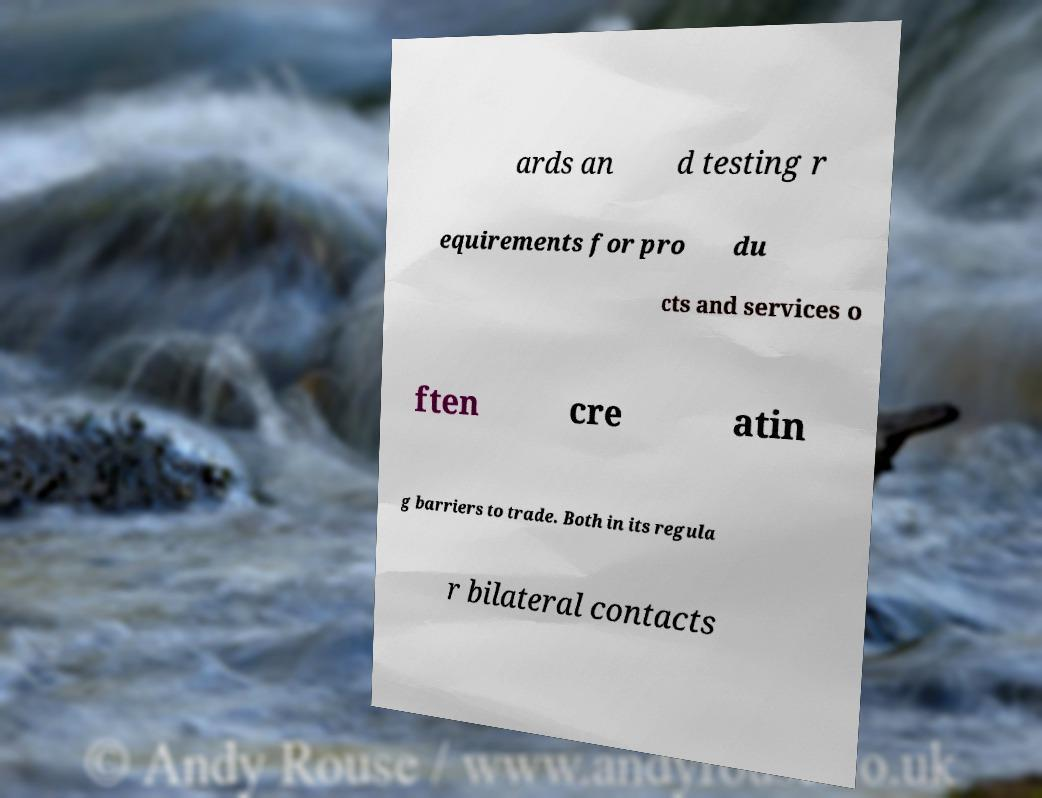I need the written content from this picture converted into text. Can you do that? ards an d testing r equirements for pro du cts and services o ften cre atin g barriers to trade. Both in its regula r bilateral contacts 